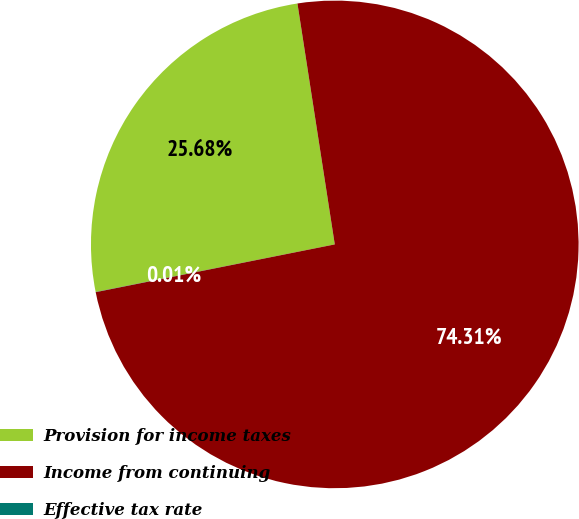<chart> <loc_0><loc_0><loc_500><loc_500><pie_chart><fcel>Provision for income taxes<fcel>Income from continuing<fcel>Effective tax rate<nl><fcel>25.68%<fcel>74.31%<fcel>0.01%<nl></chart> 